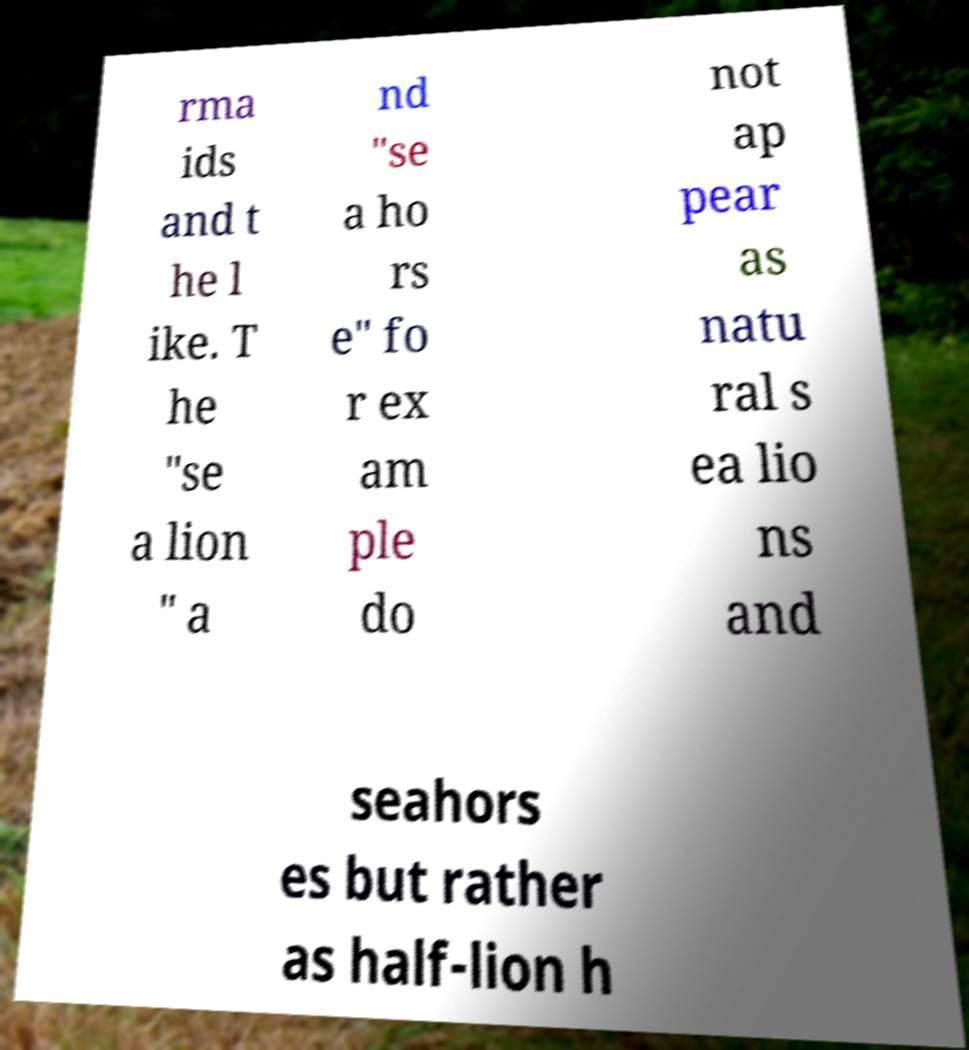For documentation purposes, I need the text within this image transcribed. Could you provide that? rma ids and t he l ike. T he "se a lion " a nd "se a ho rs e" fo r ex am ple do not ap pear as natu ral s ea lio ns and seahors es but rather as half-lion h 